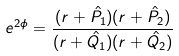<formula> <loc_0><loc_0><loc_500><loc_500>e ^ { 2 \phi } = \frac { ( r + \hat { P _ { 1 } } ) ( r + \hat { P _ { 2 } } ) } { ( r + \hat { Q _ { 1 } } ) ( r + \hat { Q _ { 2 } } ) }</formula> 